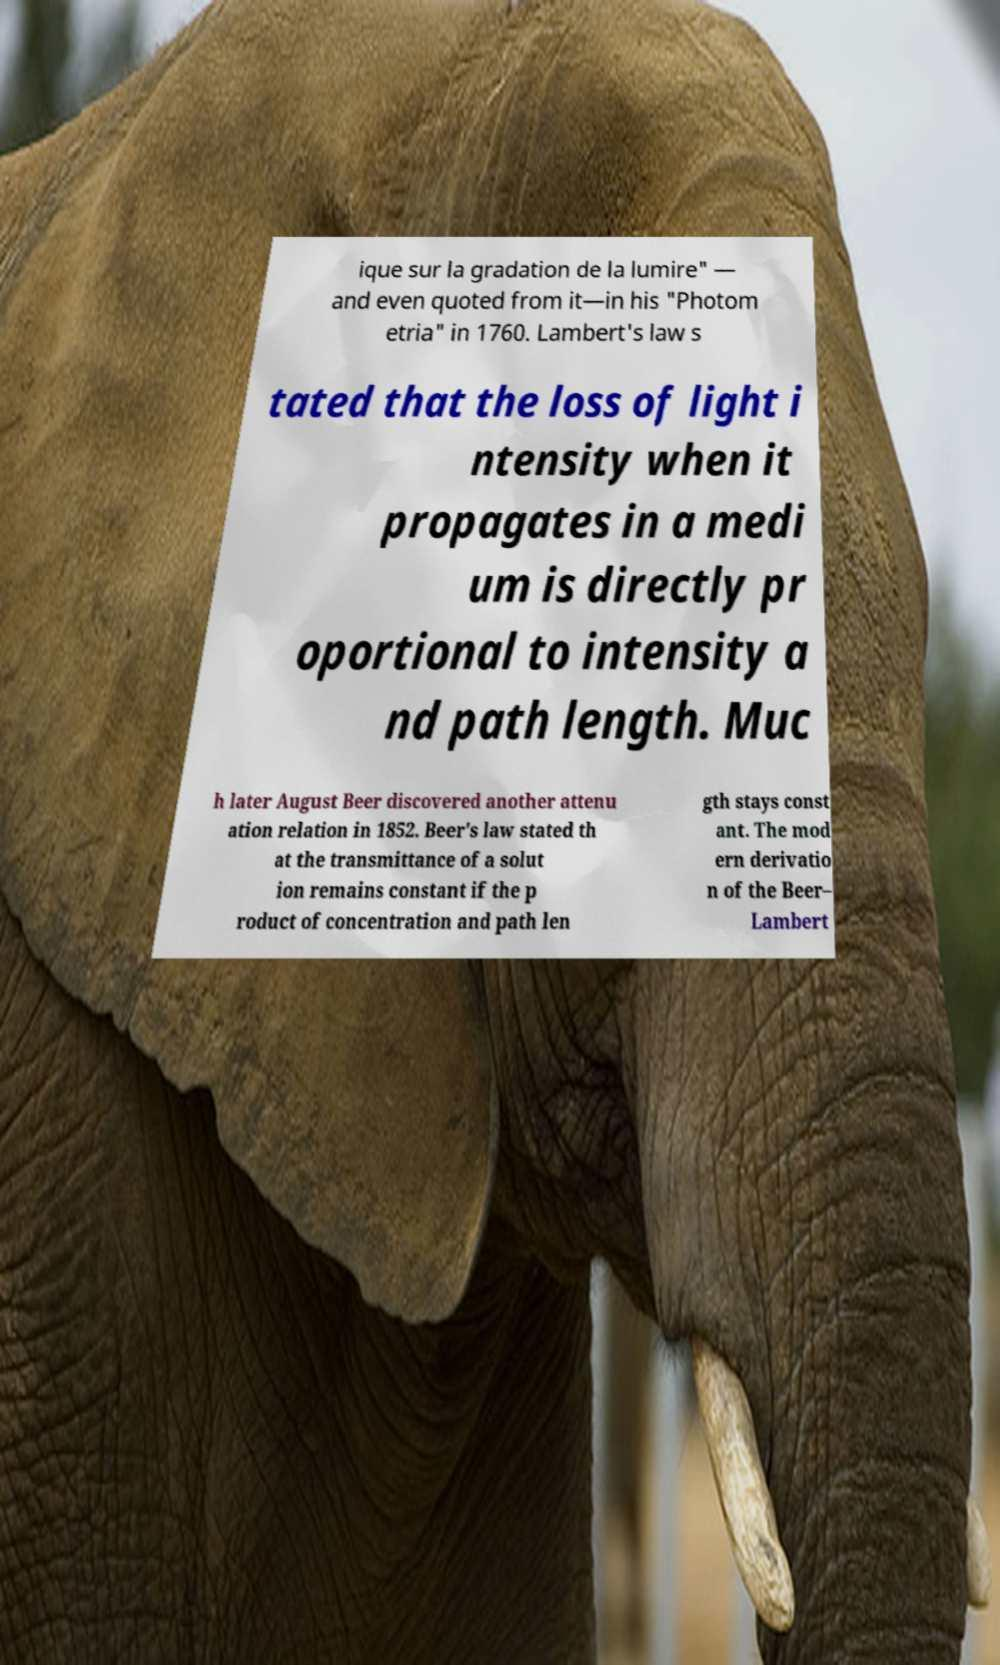Please read and relay the text visible in this image. What does it say? ique sur la gradation de la lumire" — and even quoted from it—in his "Photom etria" in 1760. Lambert's law s tated that the loss of light i ntensity when it propagates in a medi um is directly pr oportional to intensity a nd path length. Muc h later August Beer discovered another attenu ation relation in 1852. Beer's law stated th at the transmittance of a solut ion remains constant if the p roduct of concentration and path len gth stays const ant. The mod ern derivatio n of the Beer– Lambert 